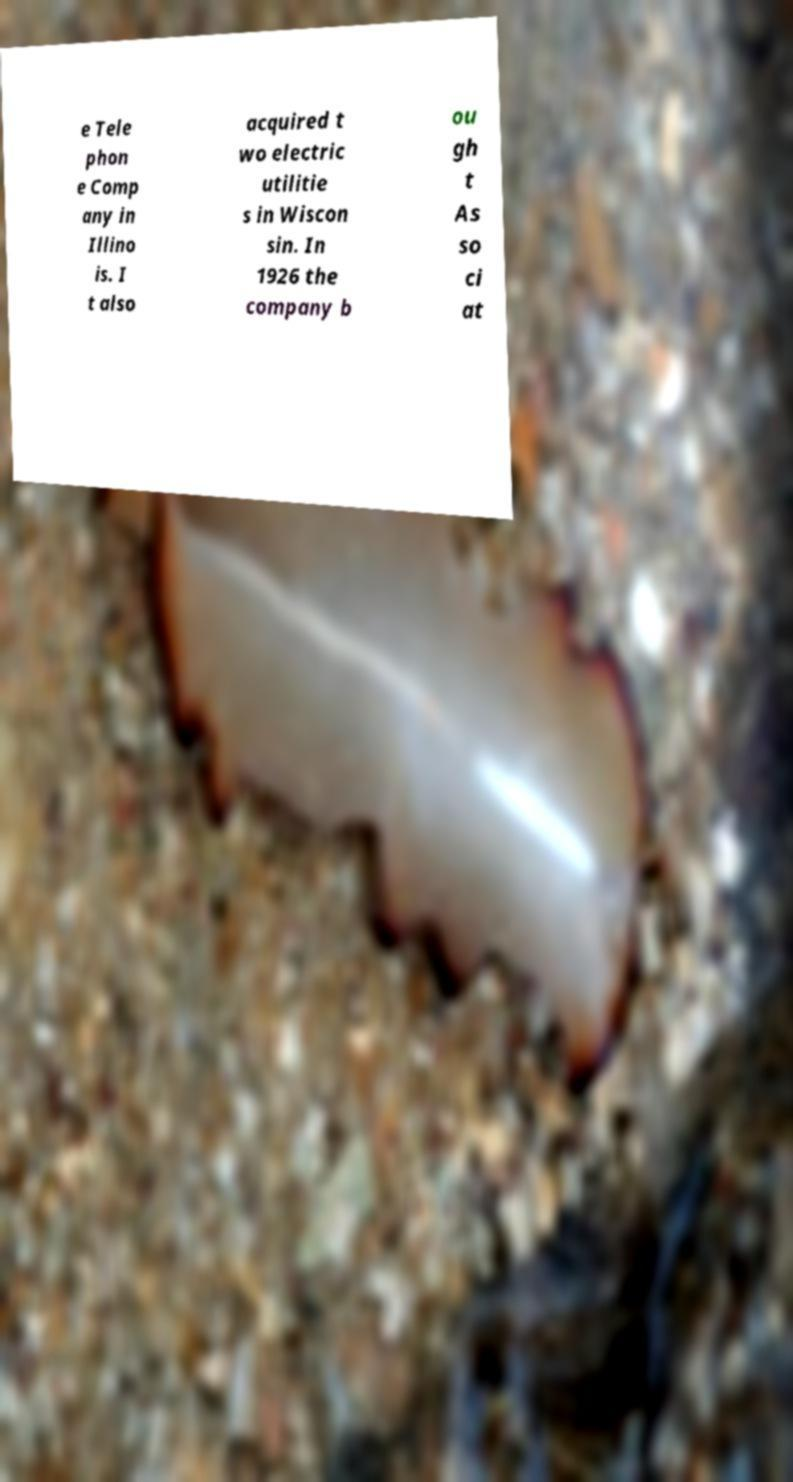I need the written content from this picture converted into text. Can you do that? e Tele phon e Comp any in Illino is. I t also acquired t wo electric utilitie s in Wiscon sin. In 1926 the company b ou gh t As so ci at 